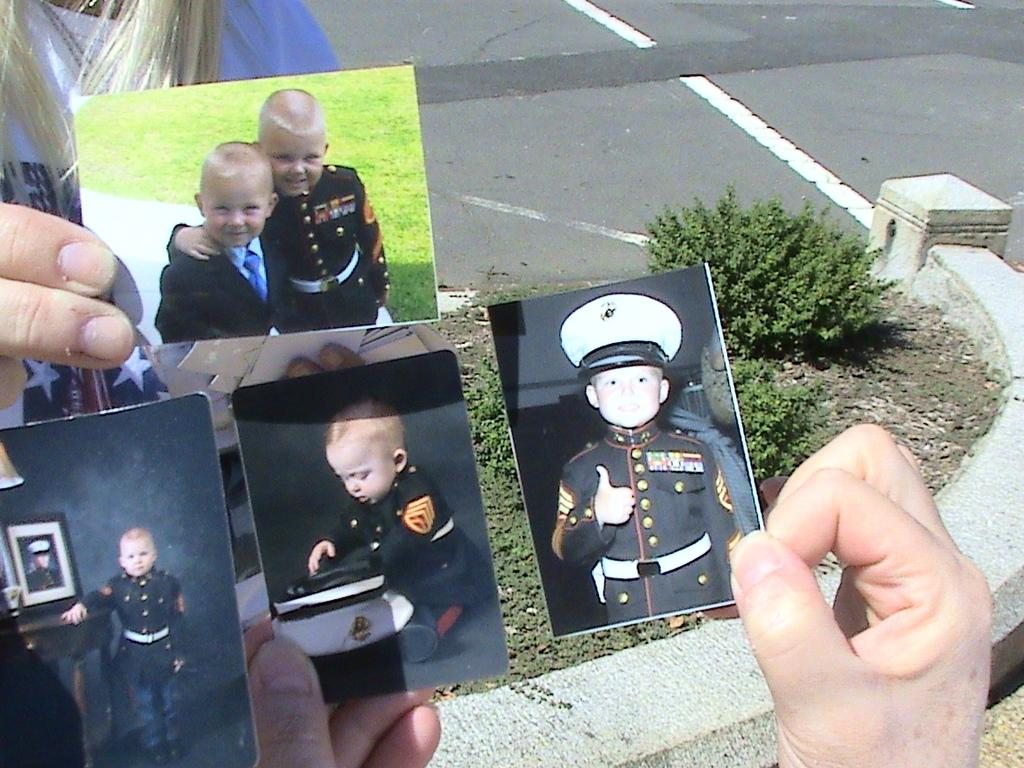How many people are in the image? There are two persons in the image. What are the persons holding in the image? The persons are holding photographs of children. What can be seen on the surface in the image? There are baby plants on the surface in the image. What type of sock is the plant wearing in the image? There is no sock or plant wearing a sock present in the image. 